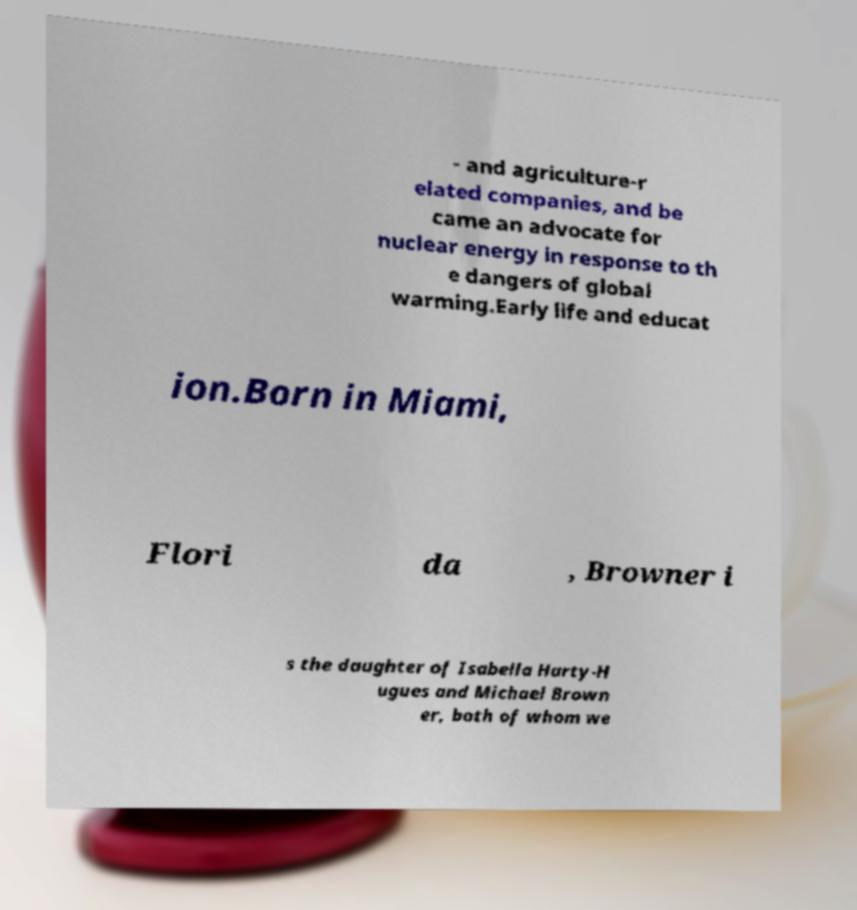Can you accurately transcribe the text from the provided image for me? - and agriculture-r elated companies, and be came an advocate for nuclear energy in response to th e dangers of global warming.Early life and educat ion.Born in Miami, Flori da , Browner i s the daughter of Isabella Harty-H ugues and Michael Brown er, both of whom we 